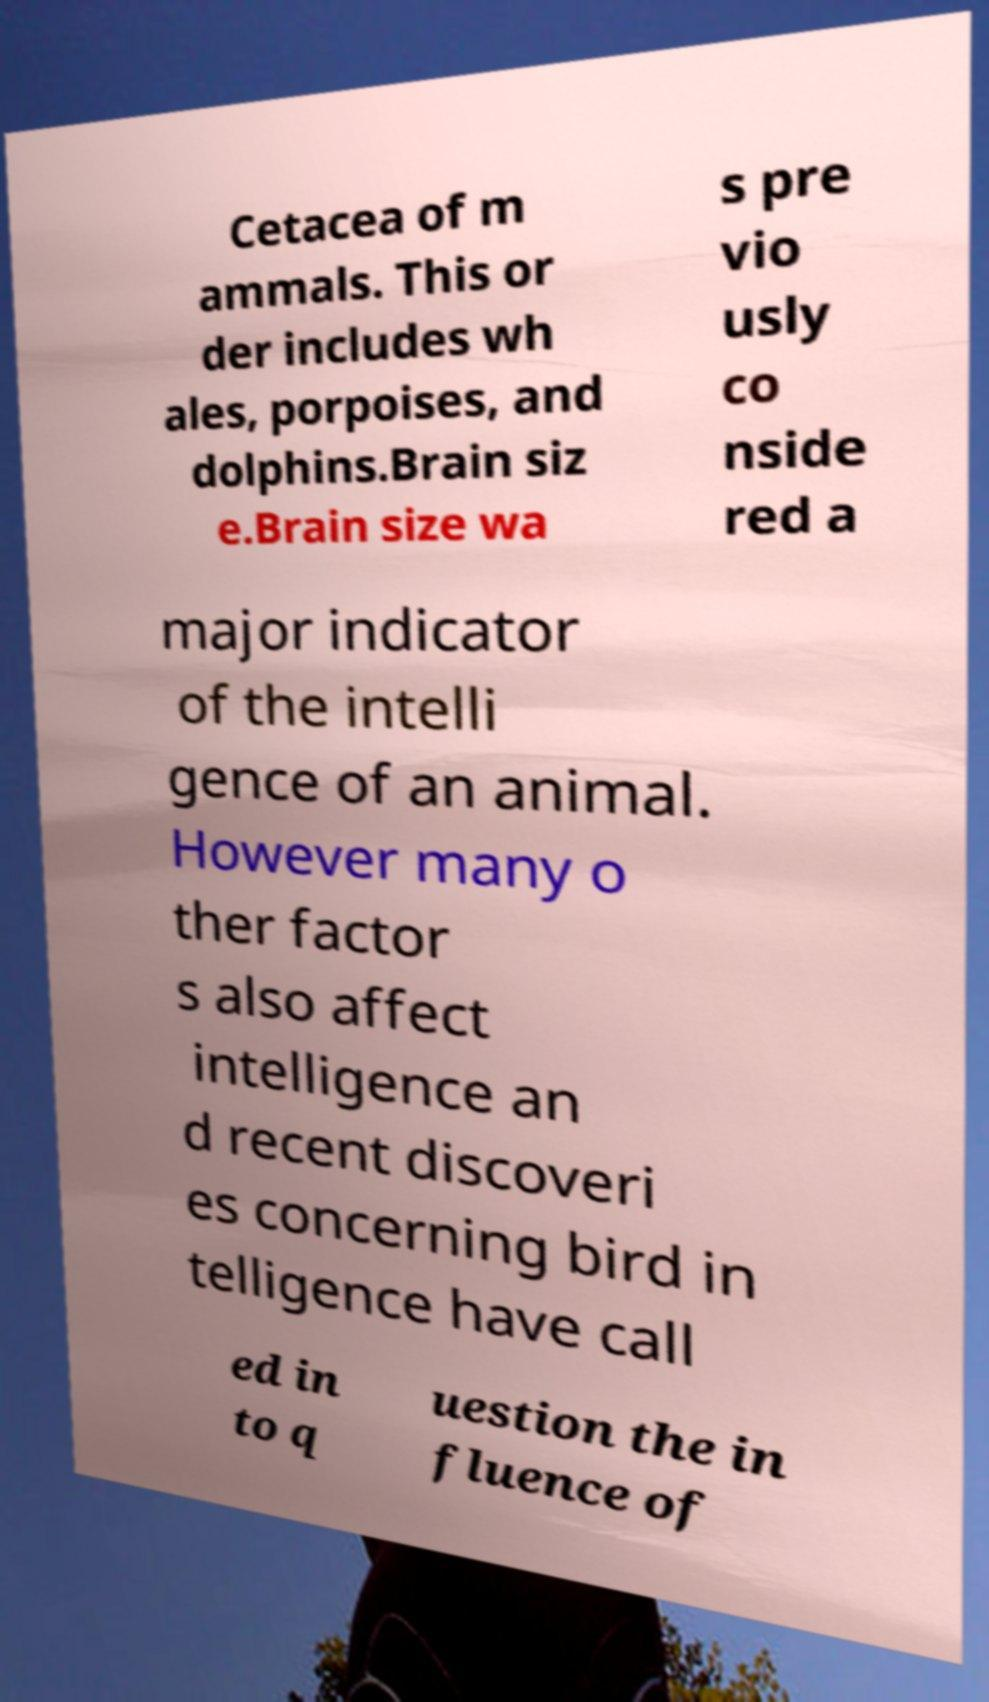Please identify and transcribe the text found in this image. Cetacea of m ammals. This or der includes wh ales, porpoises, and dolphins.Brain siz e.Brain size wa s pre vio usly co nside red a major indicator of the intelli gence of an animal. However many o ther factor s also affect intelligence an d recent discoveri es concerning bird in telligence have call ed in to q uestion the in fluence of 